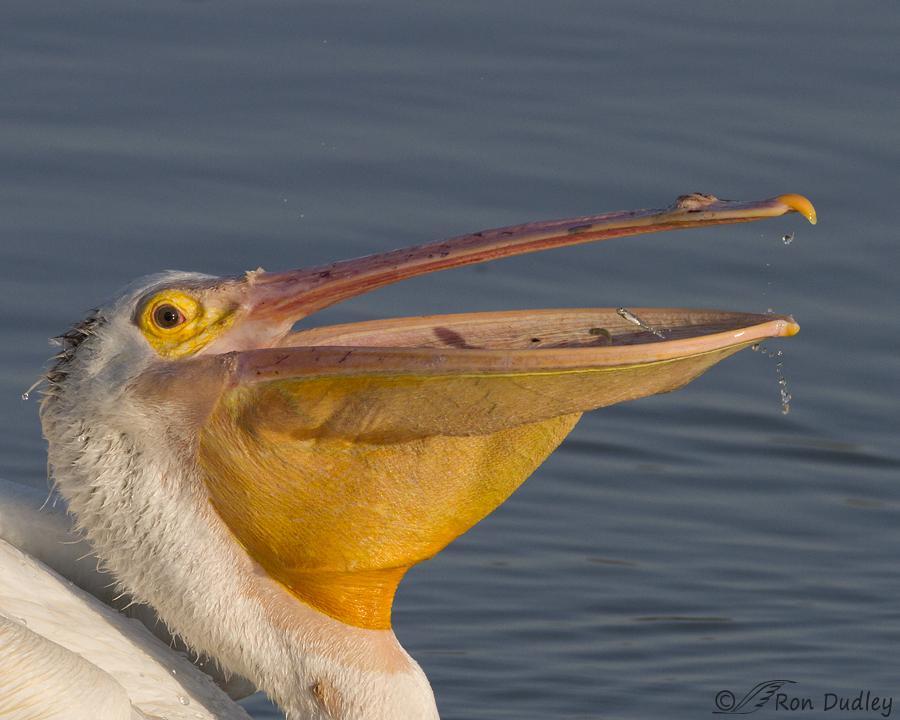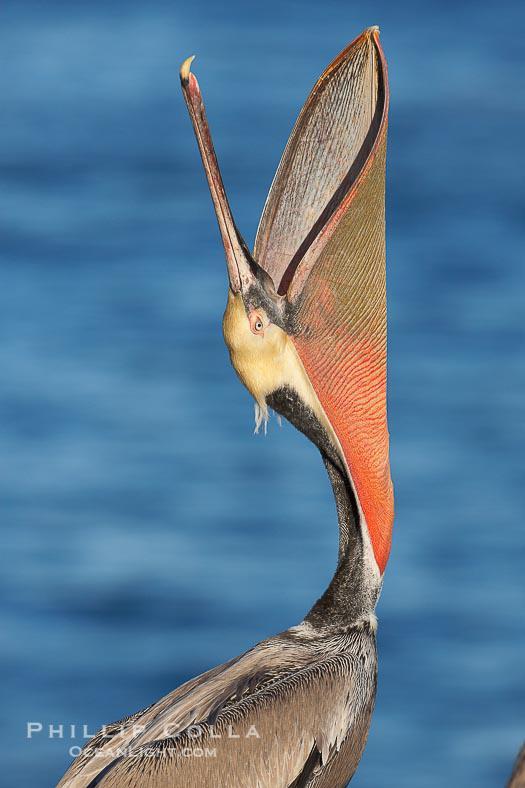The first image is the image on the left, the second image is the image on the right. Considering the images on both sides, is "Right image shows a dark gray bird with a sac-like expanded lower bill." valid? Answer yes or no. Yes. The first image is the image on the left, the second image is the image on the right. Assess this claim about the two images: "At least two fishes are in a bird's mouth.". Correct or not? Answer yes or no. No. 